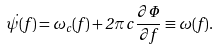Convert formula to latex. <formula><loc_0><loc_0><loc_500><loc_500>\dot { \psi } ( f ) = \omega _ { c } ( f ) + 2 \pi \, c \, \frac { \partial \Phi } { \partial f } \equiv \omega ( f ) .</formula> 